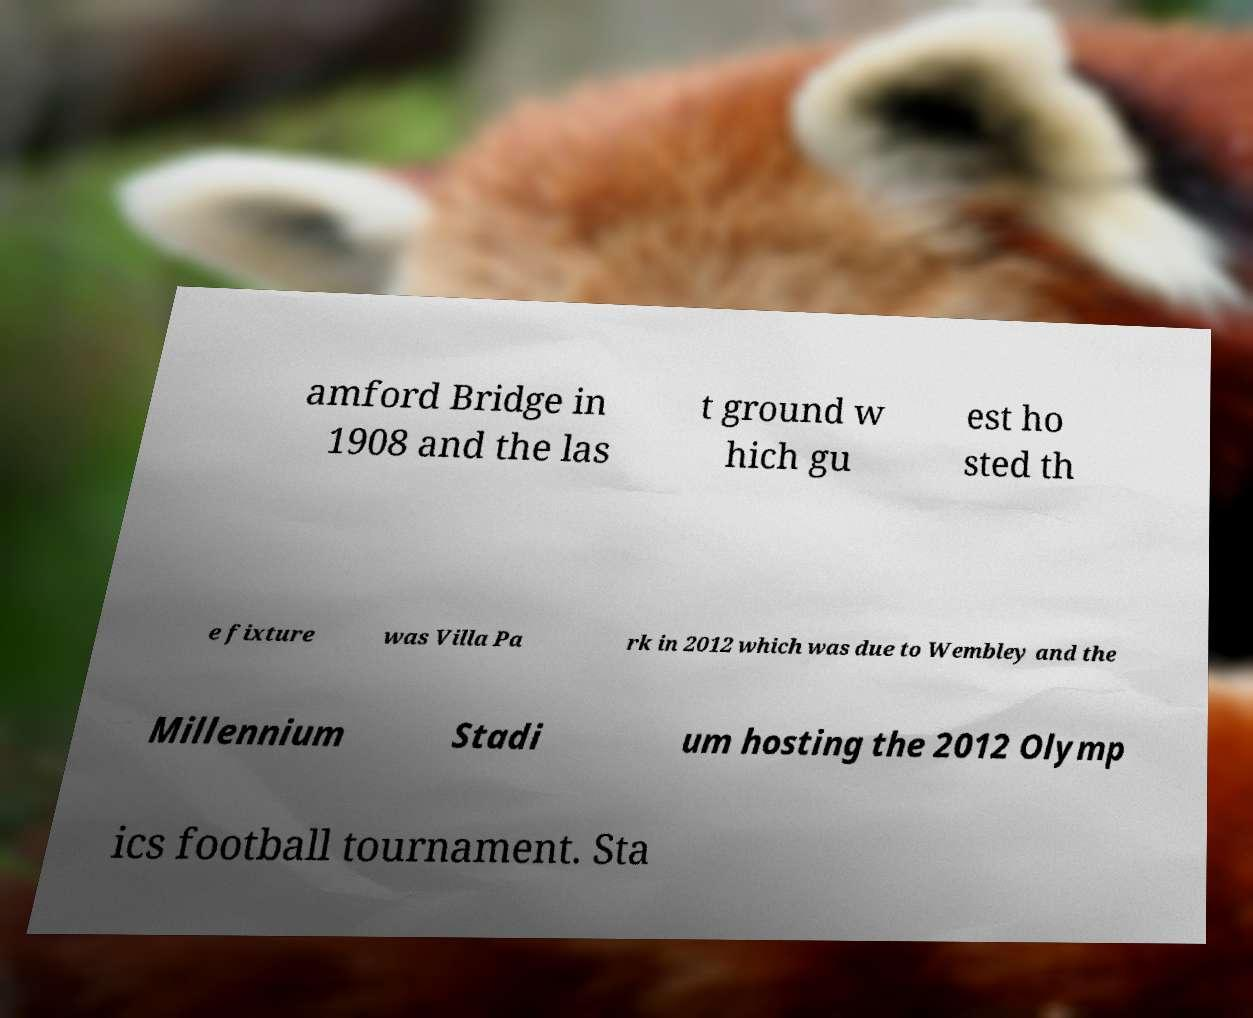Could you assist in decoding the text presented in this image and type it out clearly? amford Bridge in 1908 and the las t ground w hich gu est ho sted th e fixture was Villa Pa rk in 2012 which was due to Wembley and the Millennium Stadi um hosting the 2012 Olymp ics football tournament. Sta 